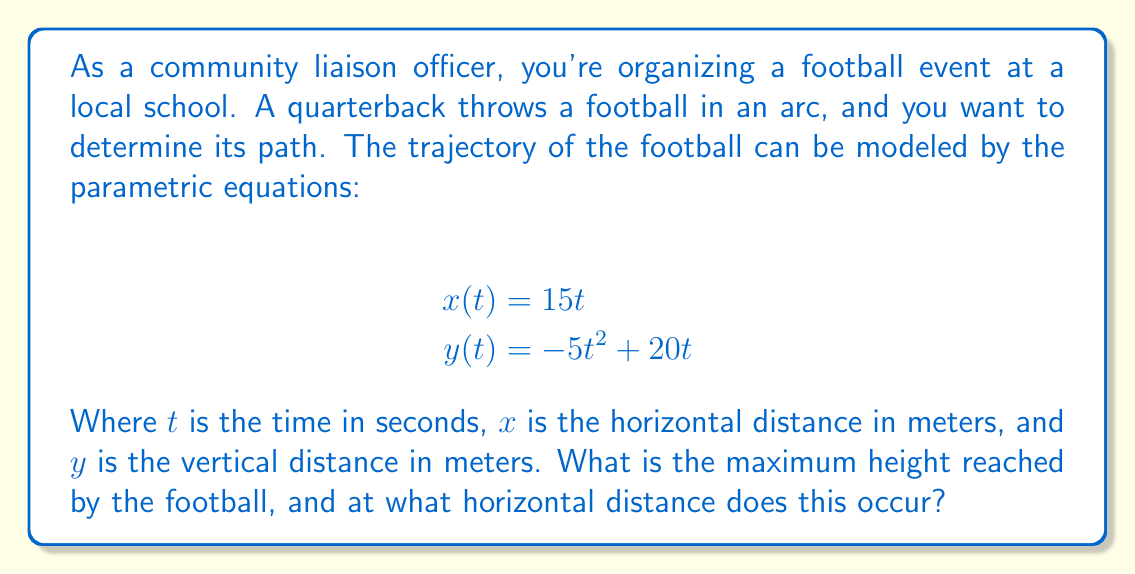Give your solution to this math problem. To solve this problem, we'll follow these steps:

1) The maximum height occurs when the vertical velocity is zero. We can find this by taking the derivative of $y(t)$ with respect to $t$ and setting it to zero.

2) $\frac{dy}{dt} = -10t + 20$

3) Set this equal to zero and solve for $t$:
   $-10t + 20 = 0$
   $-10t = -20$
   $t = 2$ seconds

4) Now that we know when the maximum height occurs, we can find the maximum height by plugging $t=2$ into the equation for $y(t)$:

   $y(2) = -5(2)^2 + 20(2) = -20 + 40 = 20$ meters

5) To find the horizontal distance at this point, we plug $t=2$ into the equation for $x(t)$:

   $x(2) = 15(2) = 30$ meters

Therefore, the maximum height of 20 meters is reached when the ball has traveled 30 meters horizontally.
Answer: The football reaches a maximum height of 20 meters when it has traveled 30 meters horizontally. 